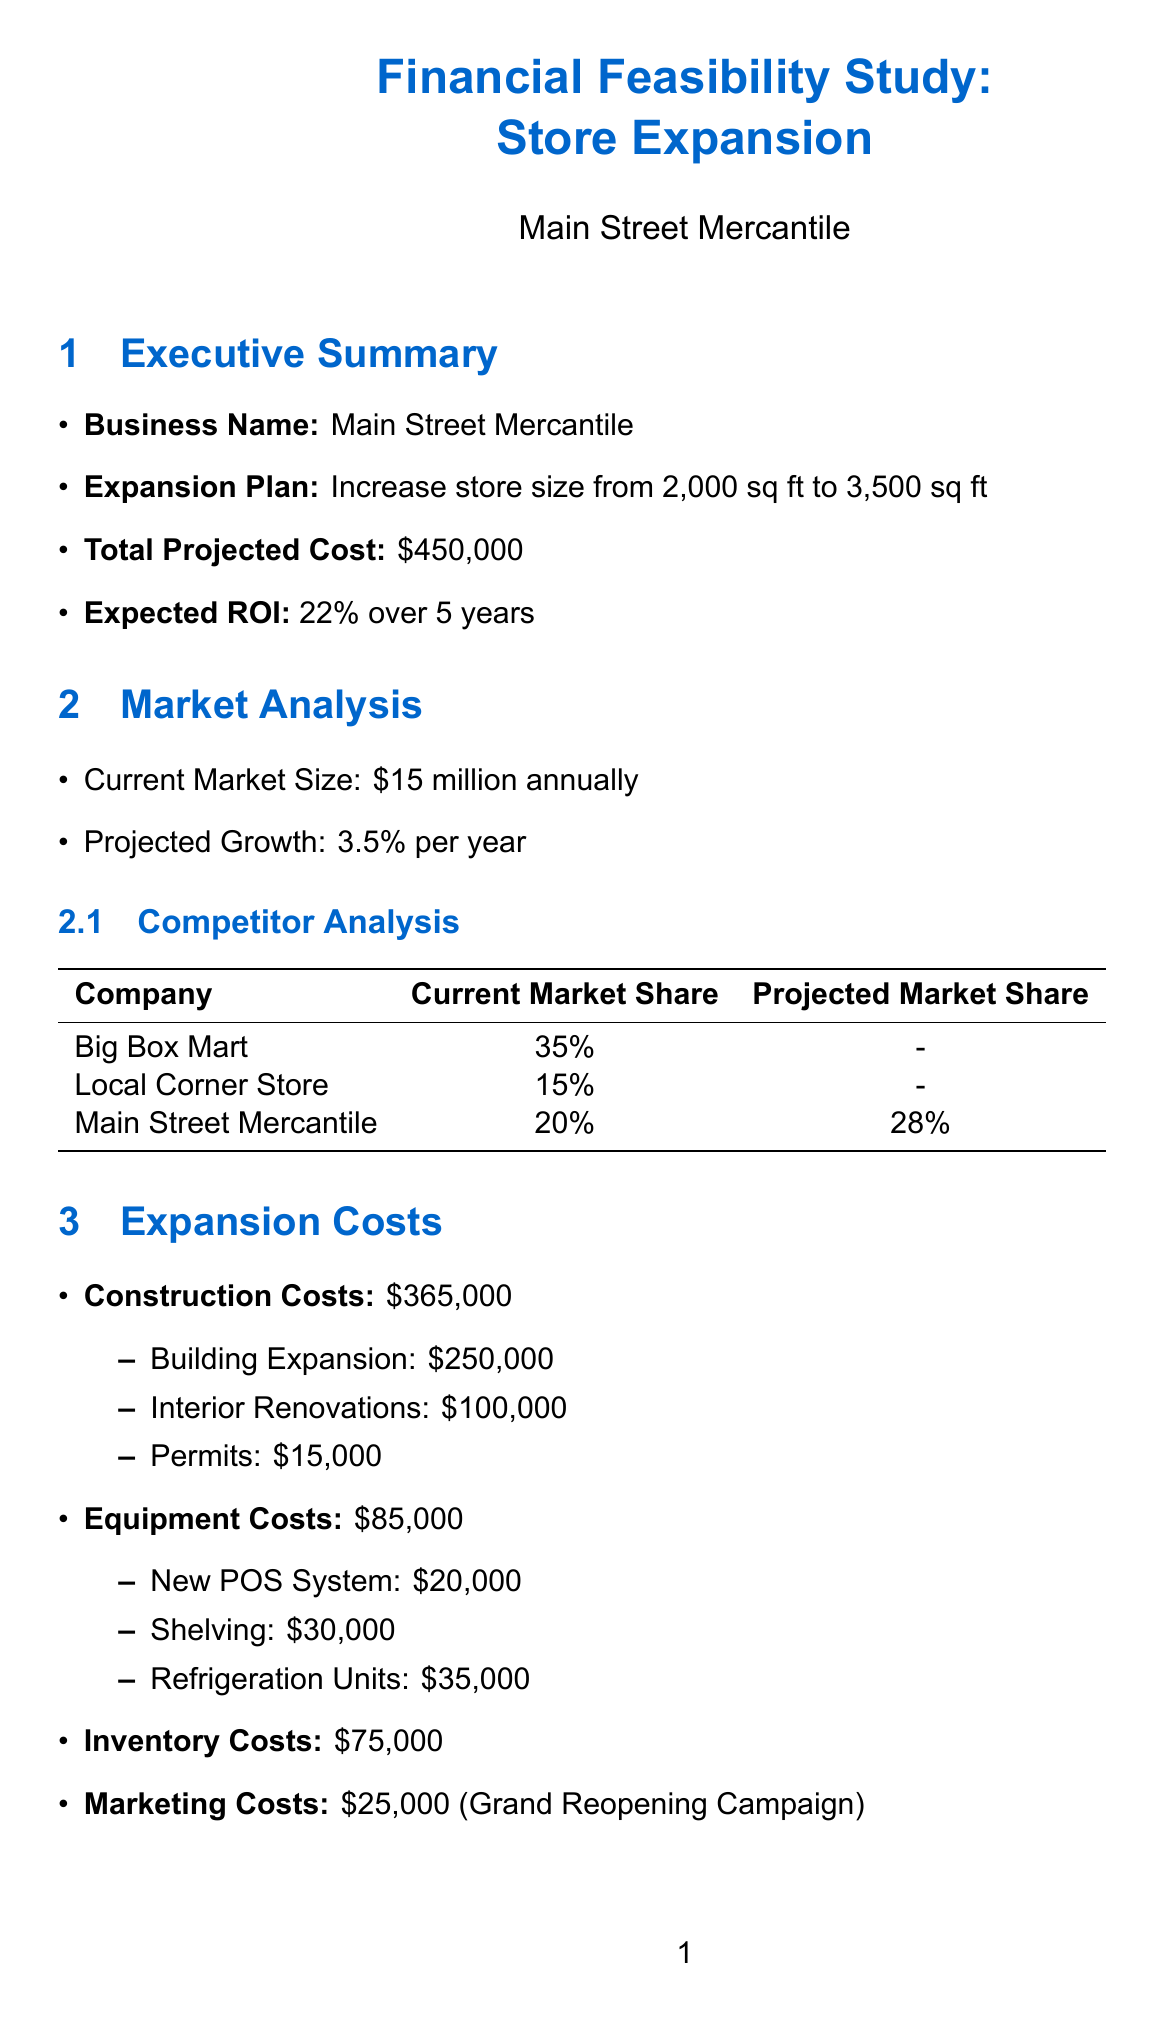What is the total projected cost of the expansion? The total projected cost is clearly stated as the sum required for expansion activities.
Answer: $450,000 What is the expected ROI over five years? The document specifies the return on investment projected over a specified time frame.
Answer: 22% What is the current annual market size? The document provides the market size as reported for the business in its current state.
Answer: $15 million annually How many new full-time jobs will be created? The document lists the projected new jobs from the expansion.
Answer: 5 What is the projected revenue for Year 3? The projected revenue is outlined per year, detailing earnings expectations over time.
Answer: $3,025,000 Which financing option has the lowest interest rate? The comparison of financing options include interest rates, allowing for selection based on rates.
Answer: 6.5% What is a potential concern mentioned in the document? Potential concerns about the expansion are outlined under a specific section addressing community impact.
Answer: Increased traffic What is one mitigation strategy for construction delays? The document provides a list of strategies aimed at reducing risks associated with the expansion project.
Answer: Secure fixed-price contracts with contractors What is the current annual operating cost? The document specifies annual operating costs, providing a financial overview of existing expenses.
Answer: $1,600,000 